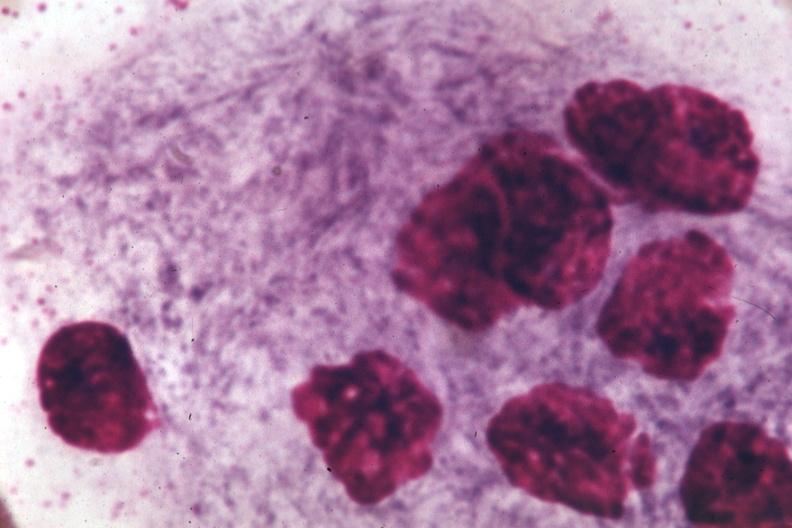what does this image show?
Answer the question using a single word or phrase. Oil immersion wrights typical cell 